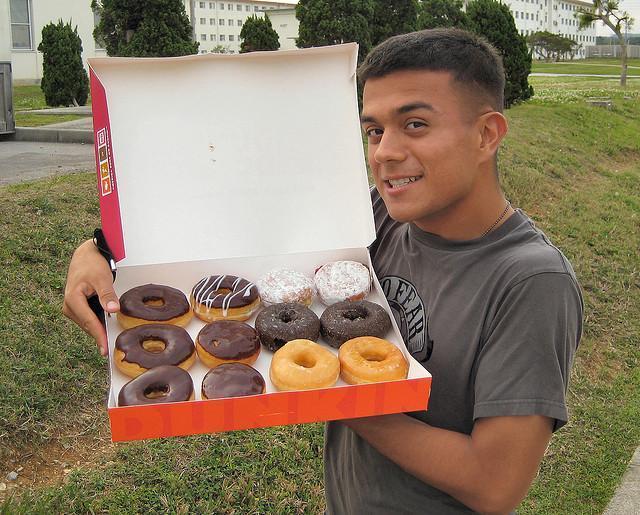How many donuts have holes?
Give a very brief answer. 8. How many doughnuts is in this box?
Give a very brief answer. 12. How many people are in the scene?
Give a very brief answer. 1. How many donuts are in the photo?
Give a very brief answer. 10. How many horses are there?
Give a very brief answer. 0. 